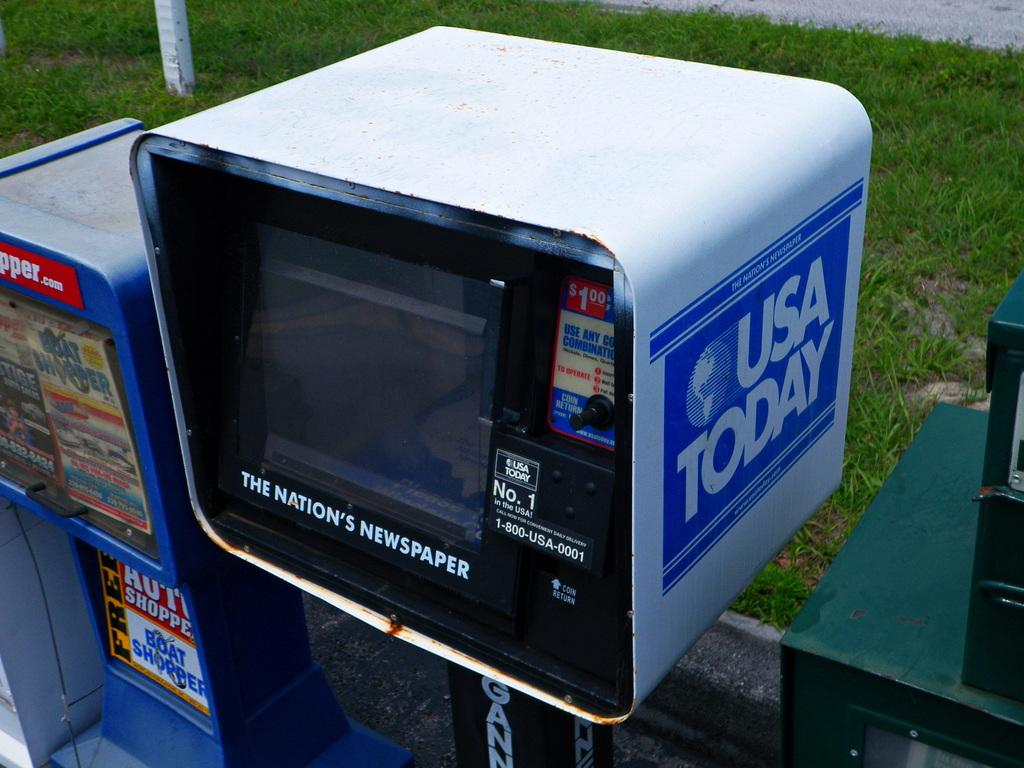<image>
Offer a succinct explanation of the picture presented. The USA Today newspaper dispenser is sitting in between other paper dispensers. 